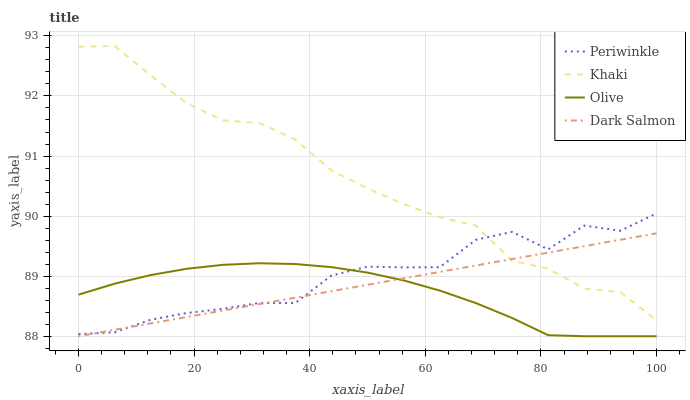Does Periwinkle have the minimum area under the curve?
Answer yes or no. No. Does Periwinkle have the maximum area under the curve?
Answer yes or no. No. Is Khaki the smoothest?
Answer yes or no. No. Is Khaki the roughest?
Answer yes or no. No. Does Periwinkle have the lowest value?
Answer yes or no. No. Does Periwinkle have the highest value?
Answer yes or no. No. Is Olive less than Khaki?
Answer yes or no. Yes. Is Khaki greater than Olive?
Answer yes or no. Yes. Does Olive intersect Khaki?
Answer yes or no. No. 